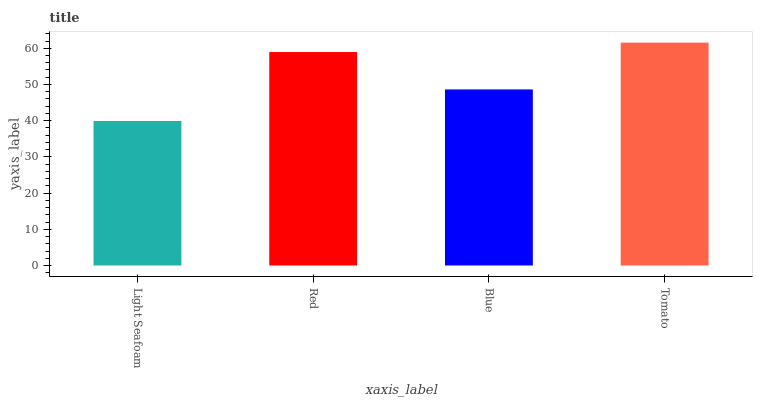Is Light Seafoam the minimum?
Answer yes or no. Yes. Is Tomato the maximum?
Answer yes or no. Yes. Is Red the minimum?
Answer yes or no. No. Is Red the maximum?
Answer yes or no. No. Is Red greater than Light Seafoam?
Answer yes or no. Yes. Is Light Seafoam less than Red?
Answer yes or no. Yes. Is Light Seafoam greater than Red?
Answer yes or no. No. Is Red less than Light Seafoam?
Answer yes or no. No. Is Red the high median?
Answer yes or no. Yes. Is Blue the low median?
Answer yes or no. Yes. Is Light Seafoam the high median?
Answer yes or no. No. Is Tomato the low median?
Answer yes or no. No. 